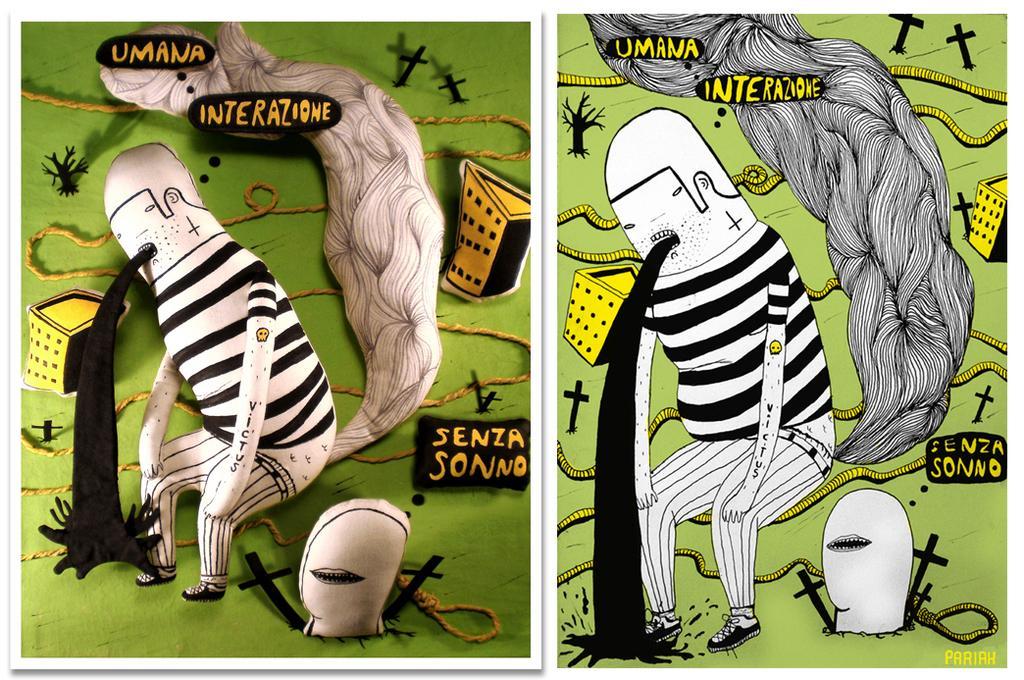How would you summarize this image in a sentence or two? This is a collage image and here we can see cartoons, buildings, ropes and we can see some text and some symbols. 